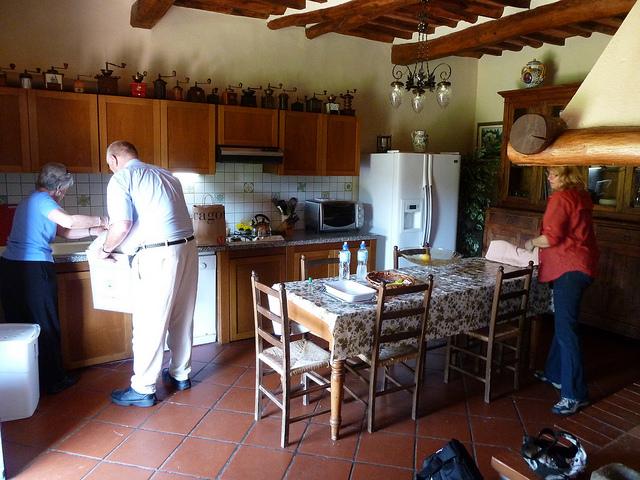Where are the bottled water?
Quick response, please. Table. Is the man wearing a belt?
Keep it brief. Yes. How many chairs do you see?
Write a very short answer. 5. 